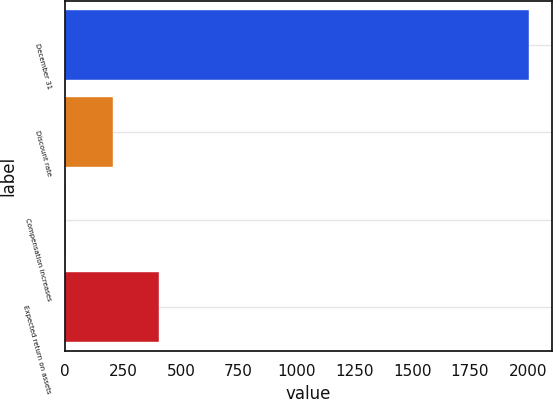Convert chart to OTSL. <chart><loc_0><loc_0><loc_500><loc_500><bar_chart><fcel>December 31<fcel>Discount rate<fcel>Compensation increases<fcel>Expected return on assets<nl><fcel>2005<fcel>205<fcel>5<fcel>405<nl></chart> 